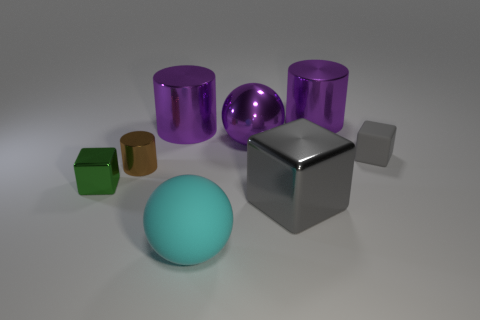Does the big metallic cube have the same color as the tiny matte object?
Your response must be concise. Yes. How many blue things are either big metallic balls or large metallic objects?
Offer a very short reply. 0. What color is the big ball that is the same material as the small gray block?
Provide a short and direct response. Cyan. Is the purple cylinder right of the big metal sphere made of the same material as the large purple cylinder that is on the left side of the big rubber ball?
Provide a succinct answer. Yes. What size is the metal cube that is the same color as the tiny rubber cube?
Your answer should be compact. Large. What material is the ball that is in front of the tiny rubber cube?
Ensure brevity in your answer.  Rubber. Does the gray object that is to the left of the tiny gray block have the same shape as the object that is in front of the big gray cube?
Give a very brief answer. No. What is the material of the other cube that is the same color as the small rubber block?
Your answer should be very brief. Metal. Are any red cubes visible?
Your answer should be compact. No. There is another gray object that is the same shape as the tiny gray object; what is it made of?
Offer a terse response. Metal. 